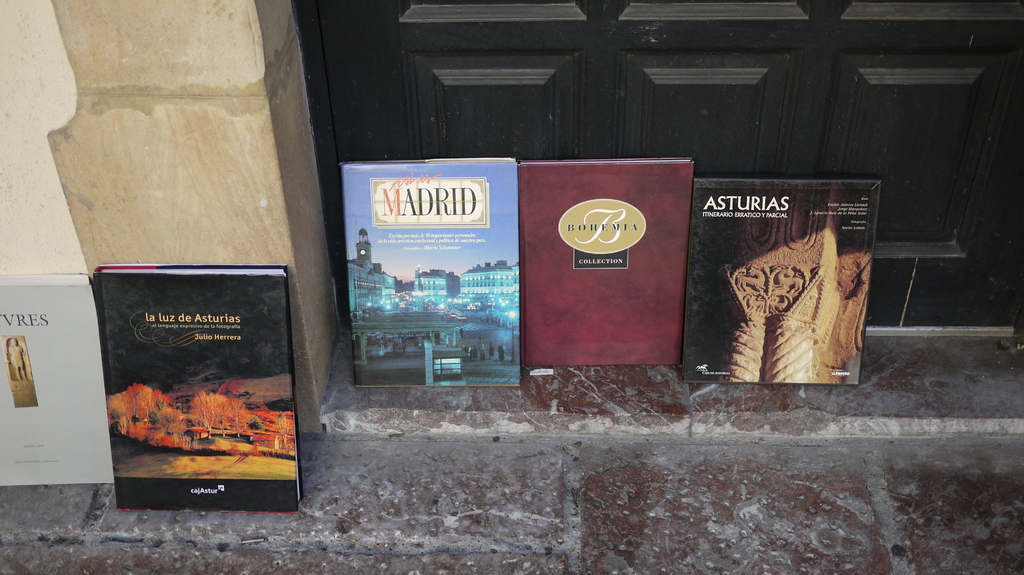Provide a one-sentence caption for the provided image. The image displays a collection of vividly colored travel and cultural books about different regions of Spain, placed thoughtfully by the entrance of a building, inviting passersby into the world of Madrid, Asturias and more. 